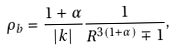Convert formula to latex. <formula><loc_0><loc_0><loc_500><loc_500>\rho _ { b } = \frac { 1 + \alpha } { | k | } \frac { 1 } { R ^ { 3 ( 1 + \alpha ) } \mp 1 } ,</formula> 